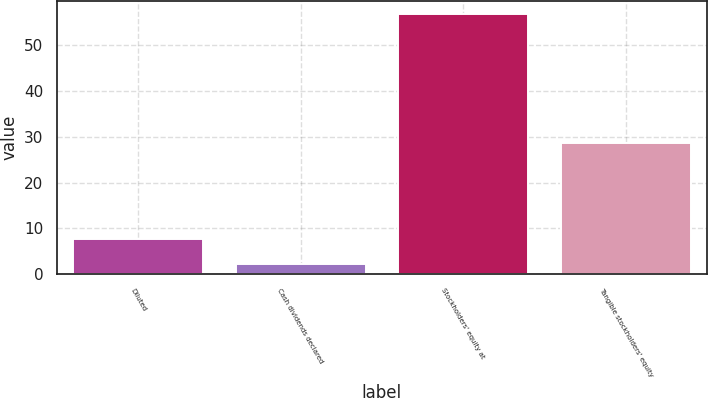Convert chart. <chart><loc_0><loc_0><loc_500><loc_500><bar_chart><fcel>Diluted<fcel>Cash dividends declared<fcel>Stockholders' equity at<fcel>Tangible stockholders' equity<nl><fcel>7.72<fcel>2.25<fcel>56.94<fcel>28.57<nl></chart> 